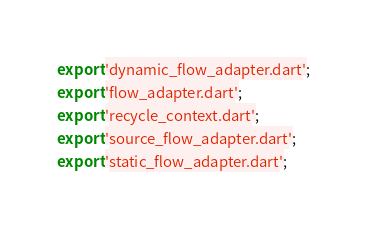<code> <loc_0><loc_0><loc_500><loc_500><_Dart_>export 'dynamic_flow_adapter.dart';
export 'flow_adapter.dart';
export 'recycle_context.dart';
export 'source_flow_adapter.dart';
export 'static_flow_adapter.dart';
</code> 